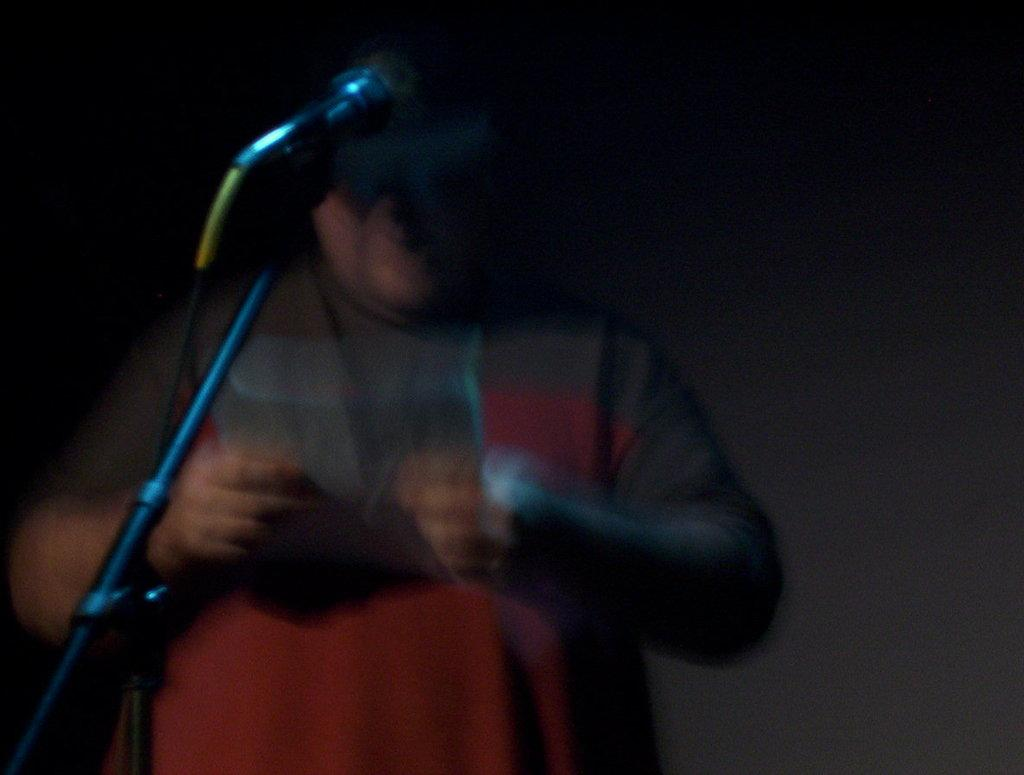Who or what is present in the image? There is a person in the image. What object can be seen alongside the person? There is a stick in the image. Can you describe the background of the image? The background of the image is dark. How many women are saying good-bye to each other in the image? There are no women or any indication of a good-bye in the image. 